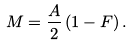<formula> <loc_0><loc_0><loc_500><loc_500>M = \frac { A } { 2 } \left ( 1 - F \right ) .</formula> 